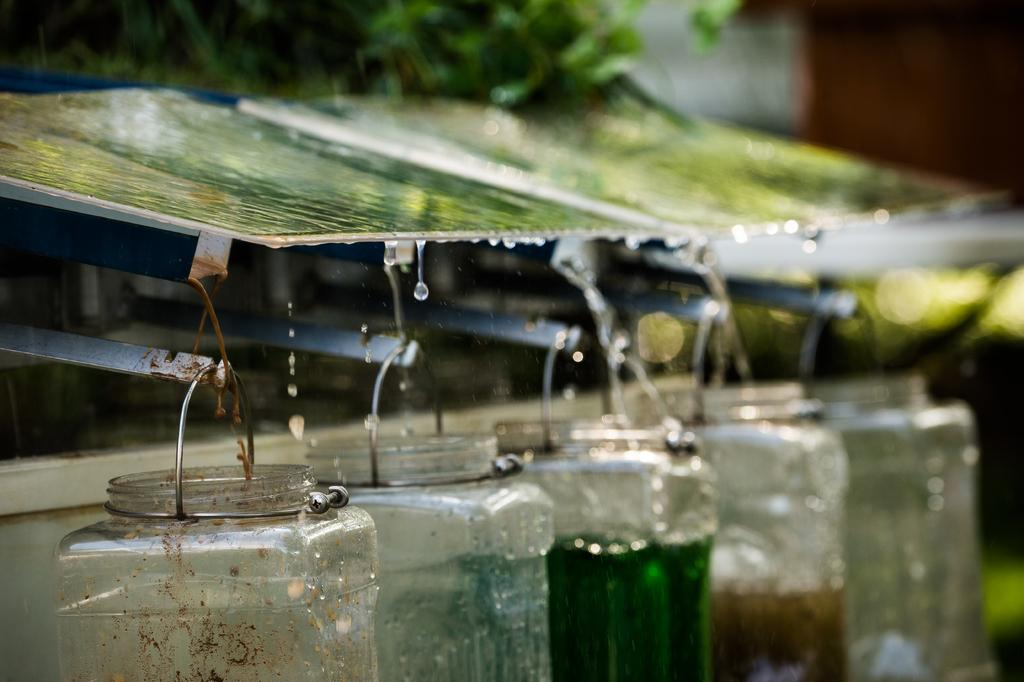What structure can be seen in the image? There is a shelter in the image. What is hanging from the rods under the shelter? Bottles are hanging from the rods under the shelter. What is the purpose of the bottles in the image? Water is being collected into the bottles. What is the price of the bead hanging from the shelter in the image? There is no bead present in the image, so it is not possible to determine its price. 